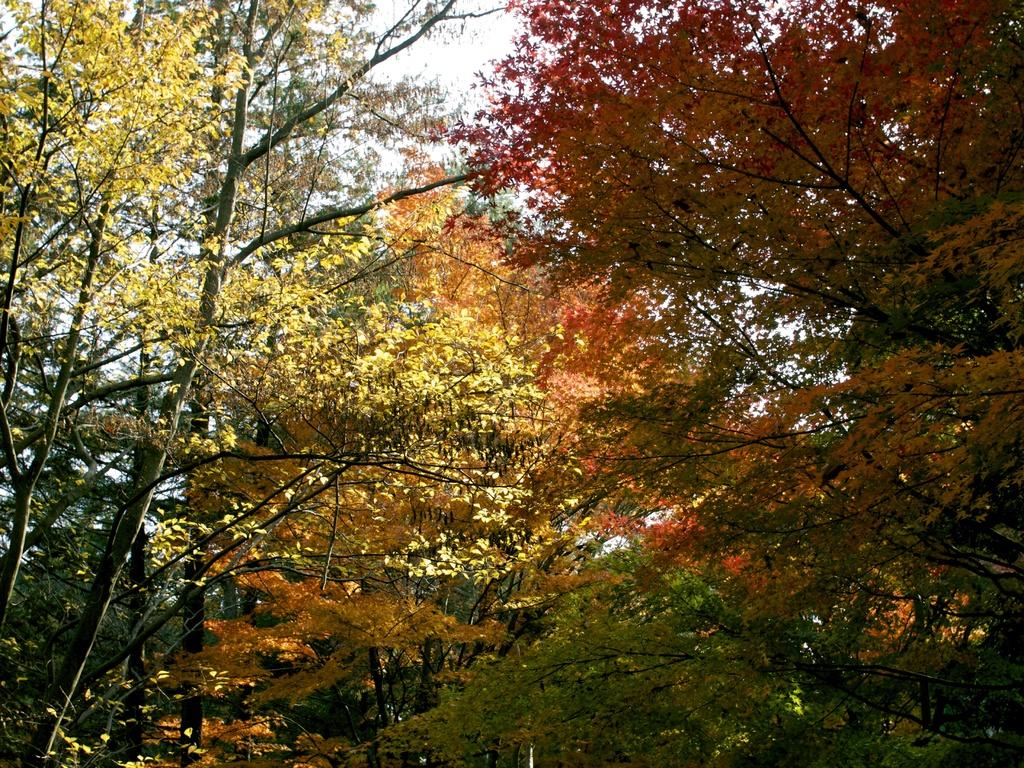What type of vegetation is present in the image? There are many trees in the image. What can be seen in the background of the image? The sky is visible in the background of the image. How many wrens can be seen in the image? There are no wrens present in the image. What other things can be found in the wilderness besides trees? The image does not show any wilderness, so it's not possible to determine what other things might be found there. 